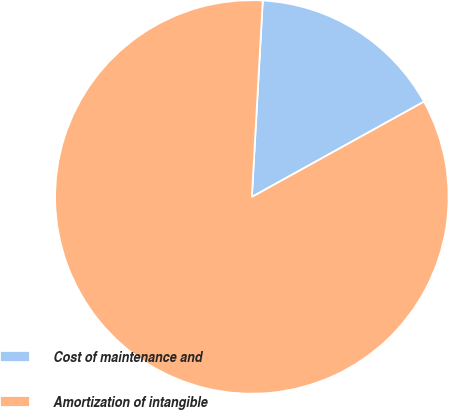Convert chart to OTSL. <chart><loc_0><loc_0><loc_500><loc_500><pie_chart><fcel>Cost of maintenance and<fcel>Amortization of intangible<nl><fcel>16.07%<fcel>83.93%<nl></chart> 